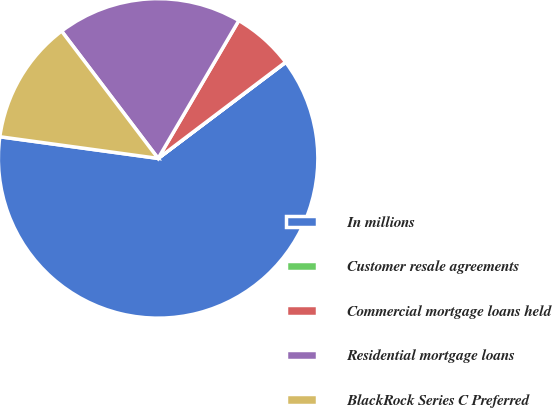Convert chart to OTSL. <chart><loc_0><loc_0><loc_500><loc_500><pie_chart><fcel>In millions<fcel>Customer resale agreements<fcel>Commercial mortgage loans held<fcel>Residential mortgage loans<fcel>BlackRock Series C Preferred<nl><fcel>62.43%<fcel>0.03%<fcel>6.27%<fcel>18.75%<fcel>12.51%<nl></chart> 